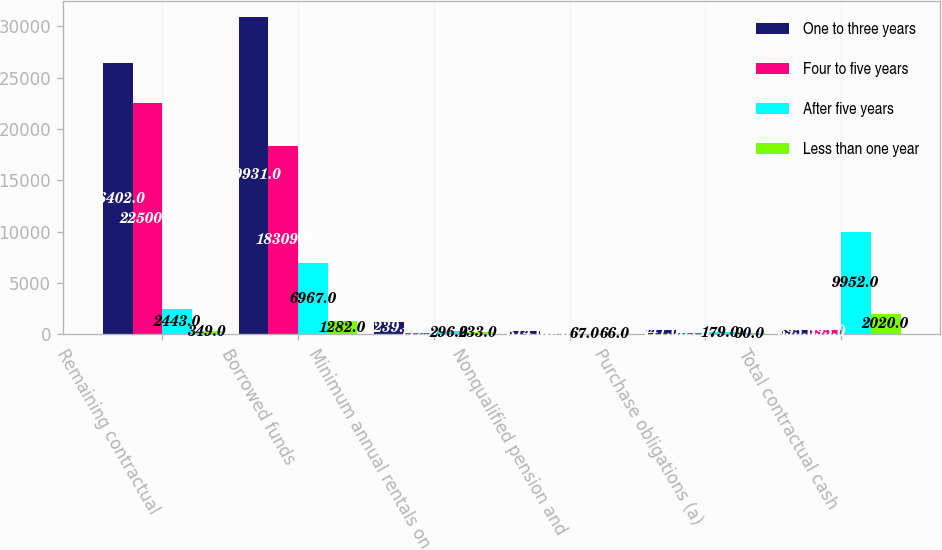<chart> <loc_0><loc_0><loc_500><loc_500><stacked_bar_chart><ecel><fcel>Remaining contractual<fcel>Borrowed funds<fcel>Minimum annual rentals on<fcel>Nonqualified pension and<fcel>Purchase obligations (a)<fcel>Total contractual cash<nl><fcel>One to three years<fcel>26402<fcel>30931<fcel>1239<fcel>314<fcel>441<fcel>395<nl><fcel>Four to five years<fcel>22500<fcel>18309<fcel>172<fcel>32<fcel>103<fcel>395<nl><fcel>After five years<fcel>2443<fcel>6967<fcel>296<fcel>67<fcel>179<fcel>9952<nl><fcel>Less than one year<fcel>349<fcel>1282<fcel>233<fcel>66<fcel>90<fcel>2020<nl></chart> 